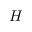Convert formula to latex. <formula><loc_0><loc_0><loc_500><loc_500>H</formula> 